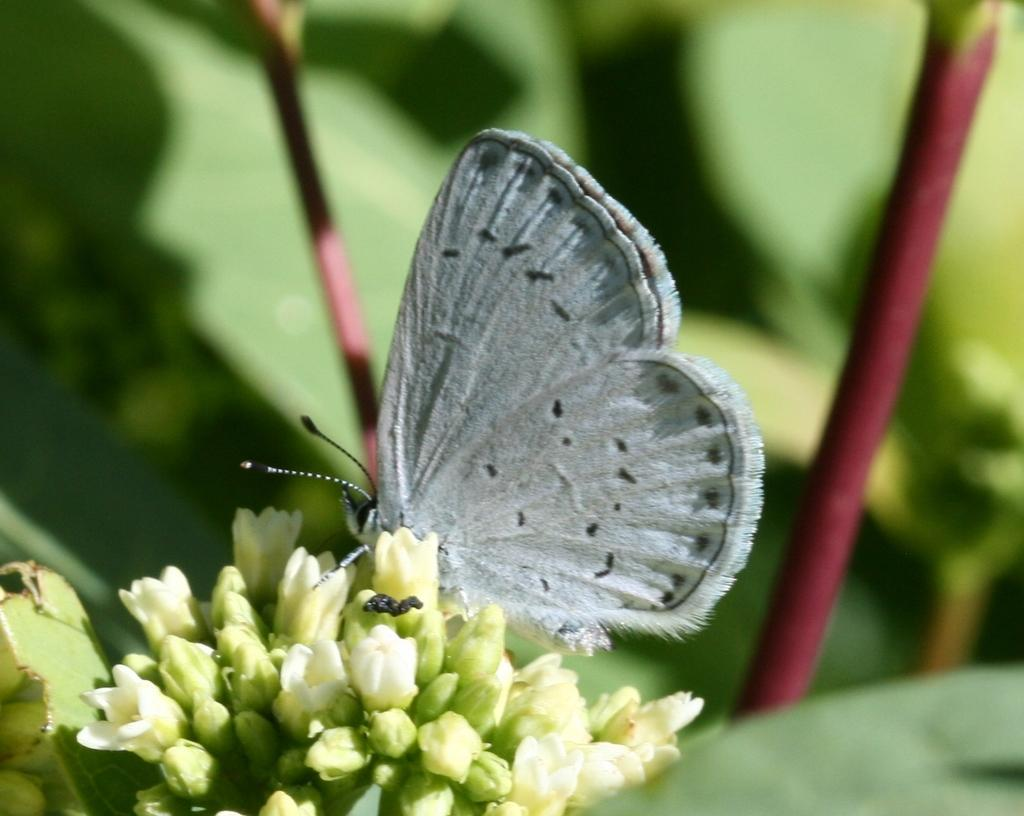What is located at the bottom of the image? There is a flower at the bottom of the image. What is on the flower? There is a butterfly on the flower. What can be seen in the background of the image? There are plants visible in the background of the image. Where is the harbor located in the image? There is no harbor present in the image. 